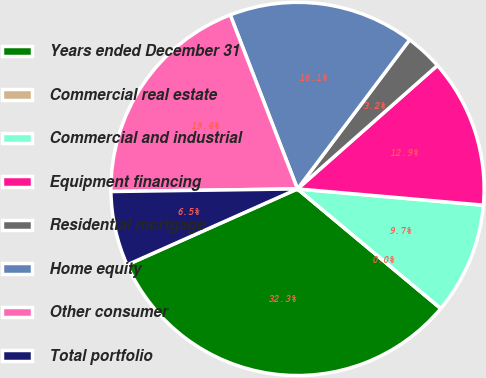Convert chart to OTSL. <chart><loc_0><loc_0><loc_500><loc_500><pie_chart><fcel>Years ended December 31<fcel>Commercial real estate<fcel>Commercial and industrial<fcel>Equipment financing<fcel>Residential mortgage<fcel>Home equity<fcel>Other consumer<fcel>Total portfolio<nl><fcel>32.26%<fcel>0.0%<fcel>9.68%<fcel>12.9%<fcel>3.23%<fcel>16.13%<fcel>19.35%<fcel>6.45%<nl></chart> 